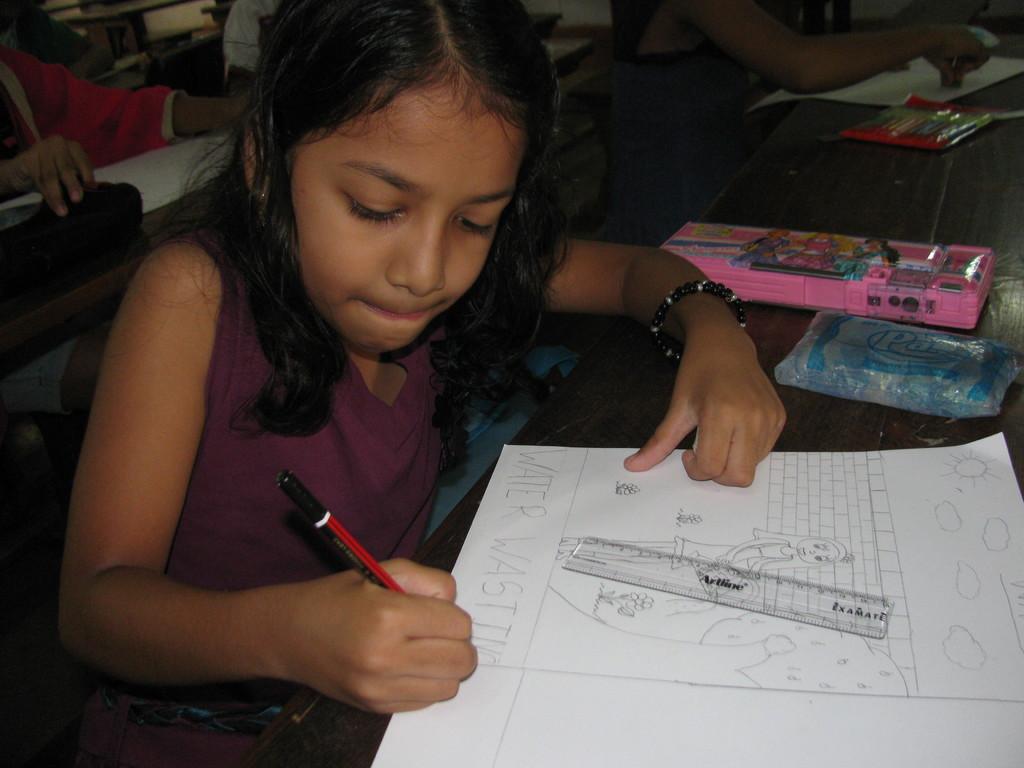How would you summarize this image in a sentence or two? There is a girl sitting and writing on a book with a pencil. There is a table. On the table there is a box, book and packets. On the book there is a scale. In the back there are many children sitting. 